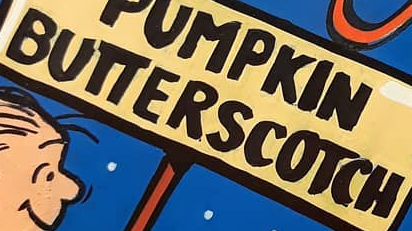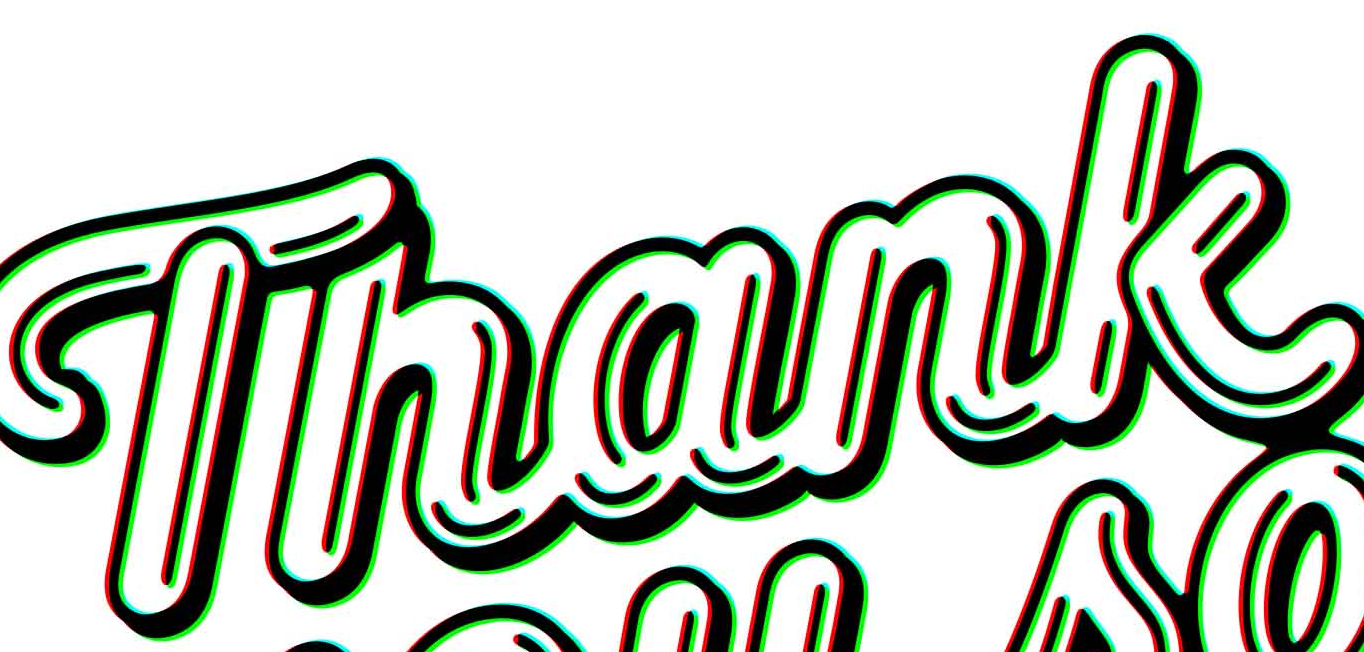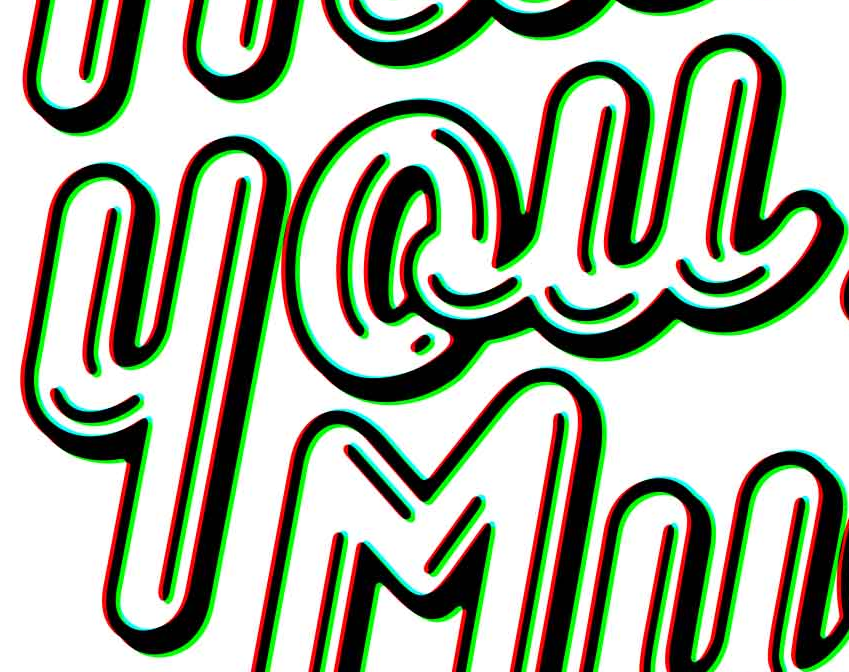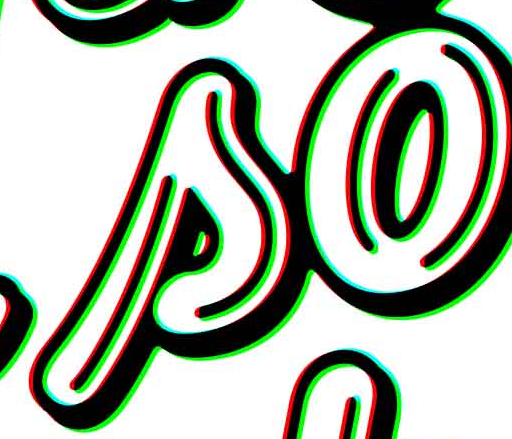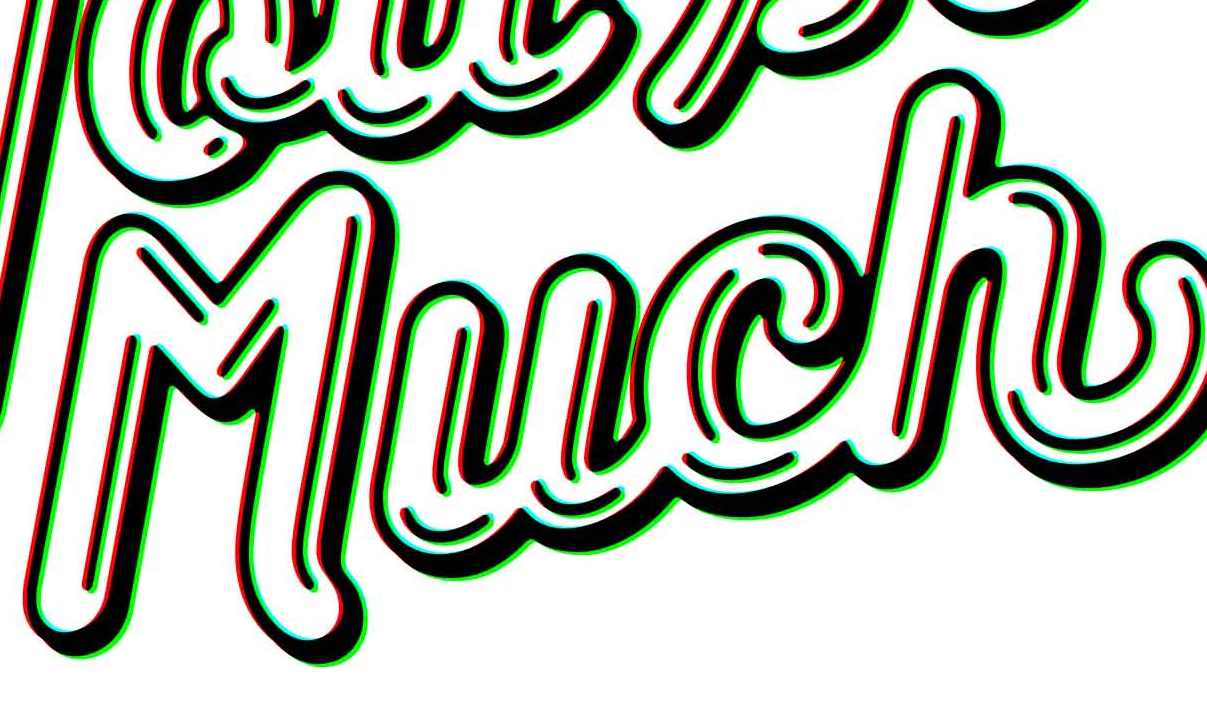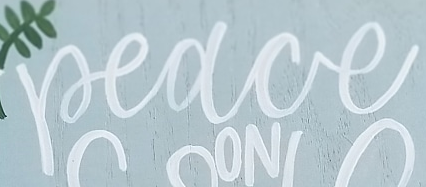What text is displayed in these images sequentially, separated by a semicolon? BUTTERSCOTCH; Thank; you; so; Much; Peace 